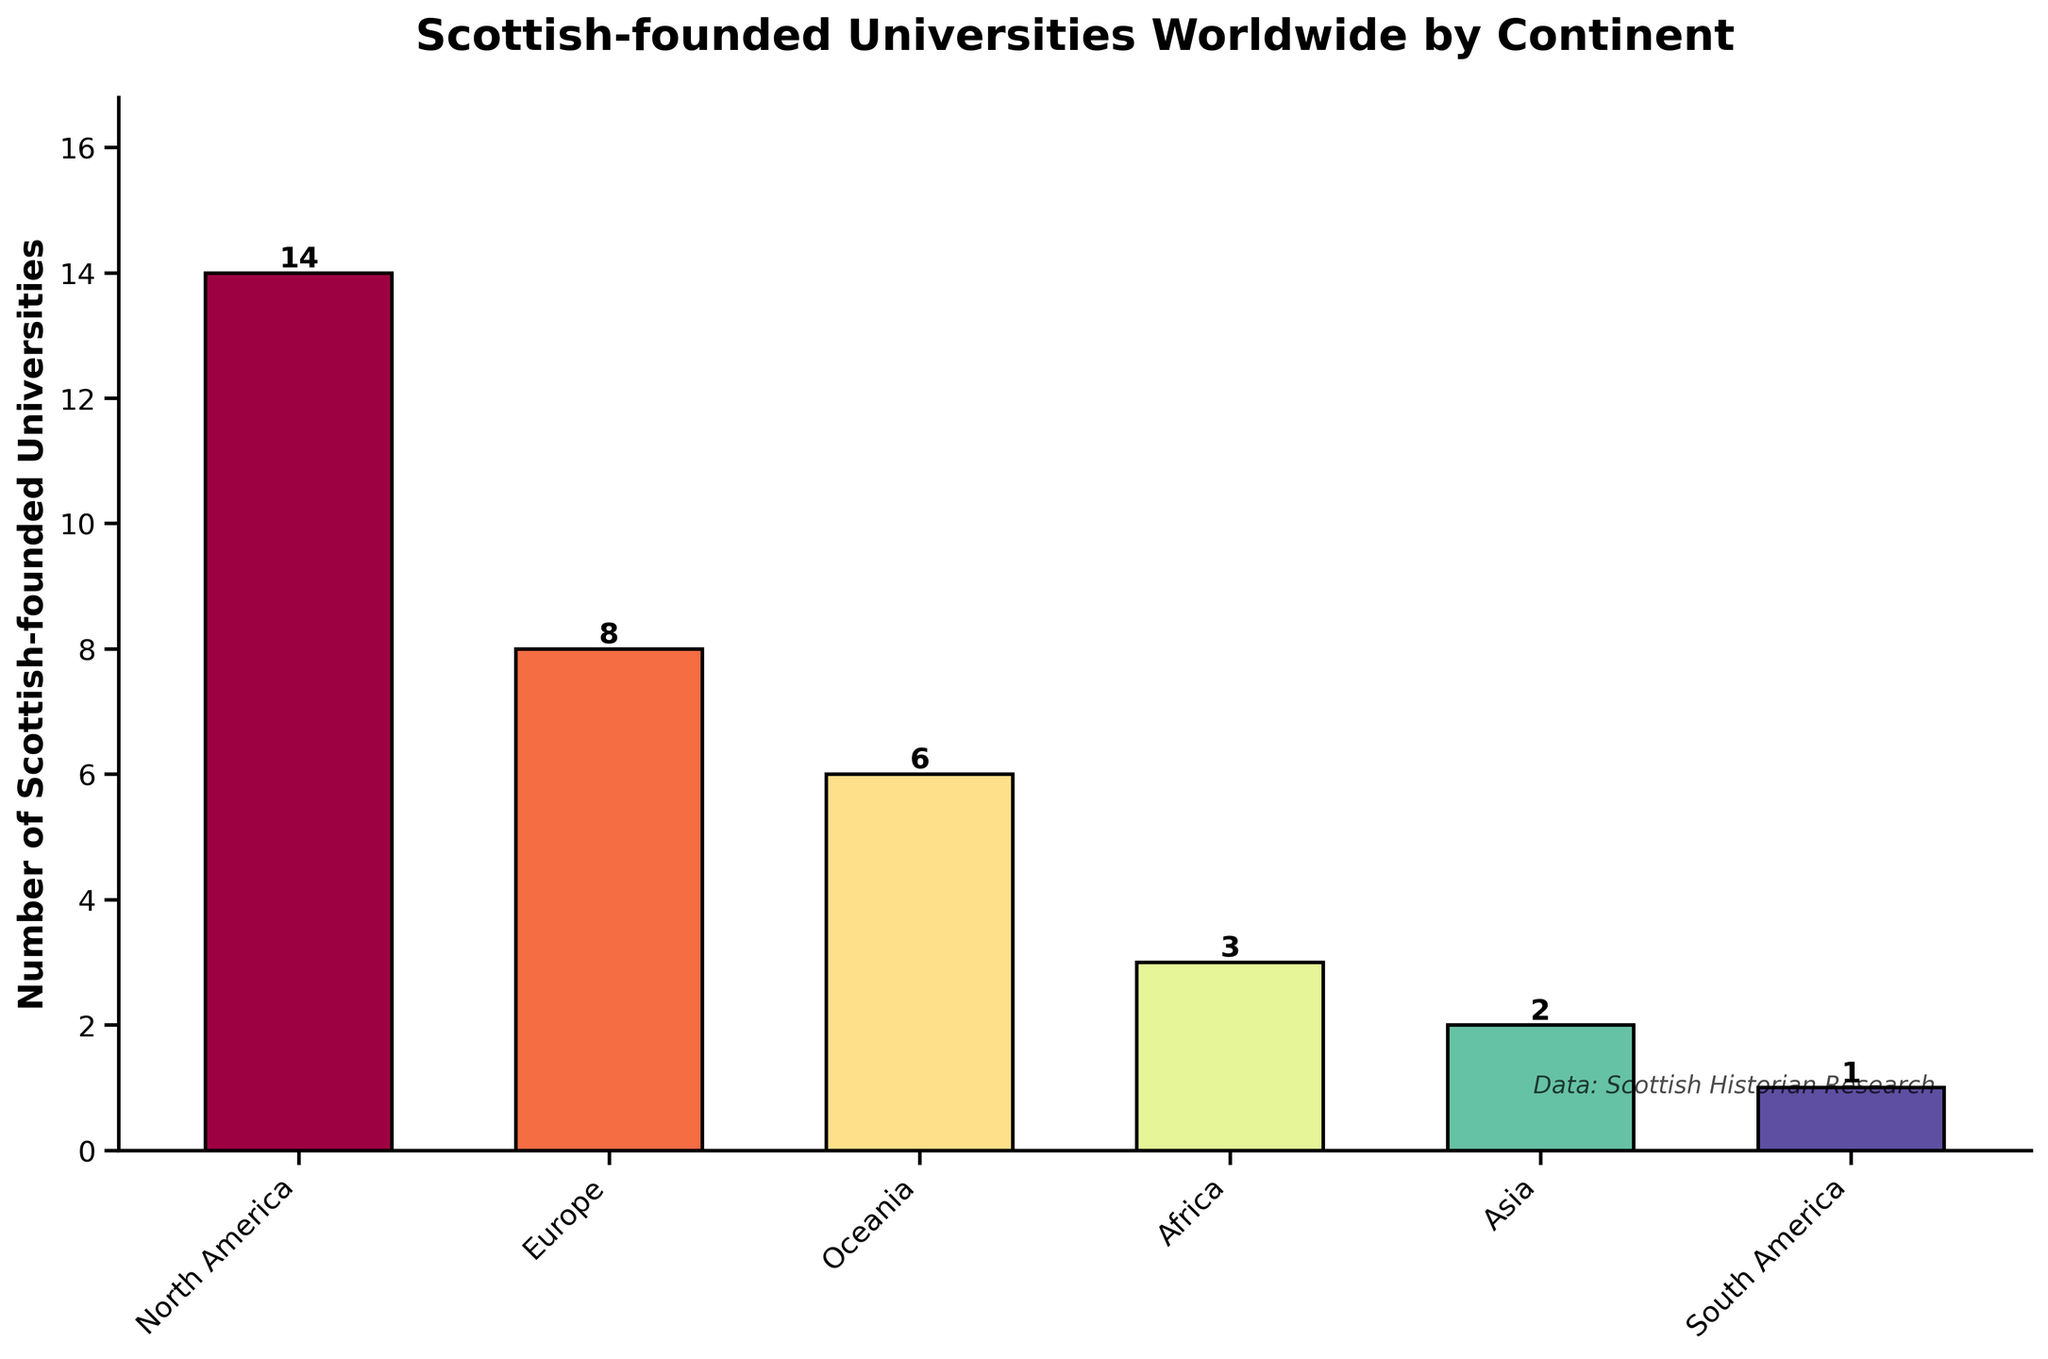Which continent has the highest number of Scottish-founded universities? By examining the height of the bars, we see the tallest bar represents North America.
Answer: North America Which continent has more Scottish-founded universities, Europe or Oceania? By comparing the height of the bars for Europe and Oceania, we see that the Europe bar is taller.
Answer: Europe What is the total number of Scottish-founded universities in North America and Asia combined? Adding the values for North America (14) and Asia (2) gives us 14 + 2.
Answer: 16 How many more Scottish-founded universities are there in North America compared to Africa? Subtracting the number in Africa (3) from the number in North America (14) gives us 14 - 3.
Answer: 11 On which continents are there fewer Scottish-founded universities than in Oceania? The number in Oceania is 6. By examining the bars, we see that Africa (3), Asia (2), and South America (1) all have fewer.
Answer: Africa, Asia, South America Are there more Scottish-founded universities in Europe and Oceania combined than in North America alone? Adding the numbers for Europe (8) and Oceania (6) gives us 8 + 6 = 14, which is equal to the number in North America (14).
Answer: No, they are equal What is the average number of Scottish-founded universities across all continents? Summing up the numbers (14 + 8 + 6 + 3 + 2 + 1) gives 34, and there are 6 continents, so 34/6 = 5.67.
Answer: 5.67 How many more Scottish-founded universities are there in the top two continents compared to the bottom two? The top two continents are North America (14) and Europe (8), summing to 22. The bottom two are Asia (2) and South America (1), summing to 3. The difference is 22 - 3.
Answer: 19 Which continent has the least number of Scottish-founded universities, and how many universities does it have? The shortest bar represents South America with a value of 1.
Answer: South America, 1 What is the combined percentage share of Scottish-founded universities in Oceania and Africa, out of the total number worldwide? Oceania has 6 and Africa has 3, so together they have 9. The total worldwide is 34, so (9/34) * 100 ≈ 26.47%.
Answer: 26.47% 